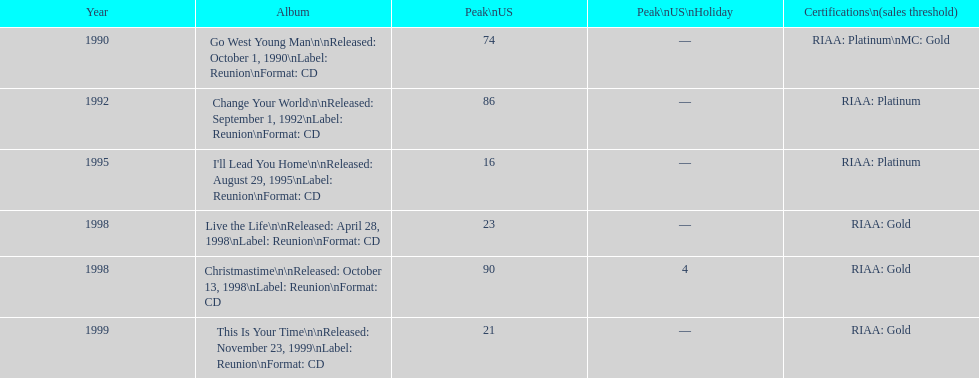Which michael w smith album had the highest ranking on the us chart? I'll Lead You Home. 